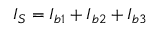Convert formula to latex. <formula><loc_0><loc_0><loc_500><loc_500>I _ { S } = I _ { b 1 } + I _ { b 2 } + I _ { b 3 }</formula> 